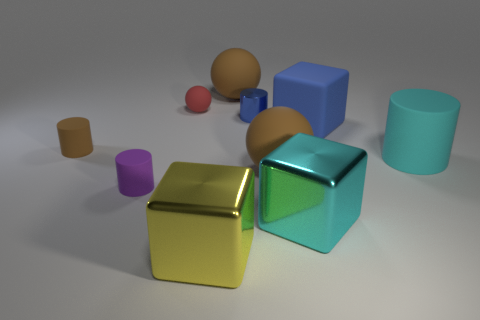What could be the purpose of such an arrangement of shapes and colors? This arrangement of shapes and colors has multiple potential purposes. It could be an artistic exploration of form and color, a demonstration for educational purposes in a setting such as a classroom to teach about shapes and colors, or perhaps a setup for a computer vision system to test object recognition algorithms. The arrangement invites viewers to consider the relationships between the objects, the play of light and shadow, and the impact of color and form in a three-dimensional space. 